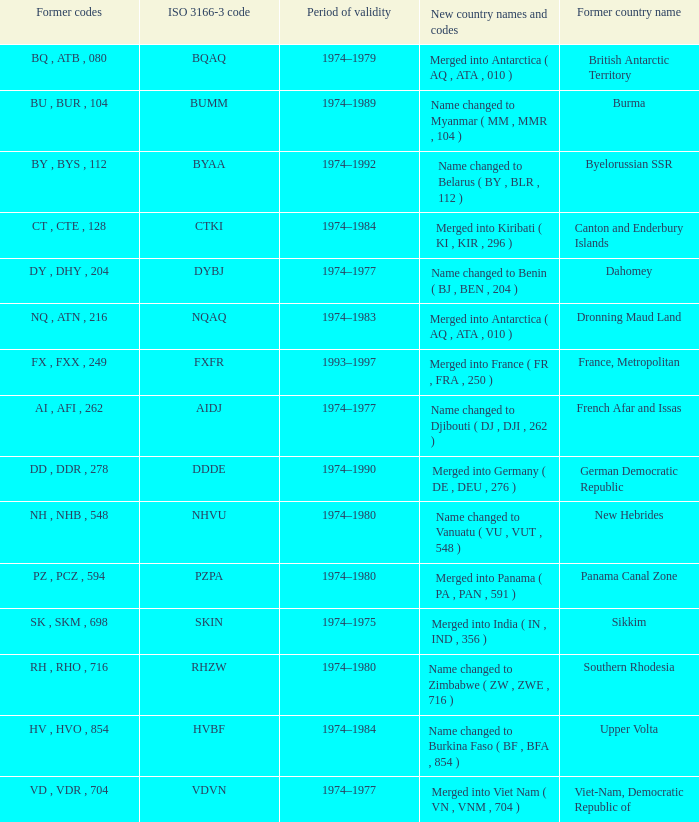Identify the complete length of validity for upper volta. 1.0. 